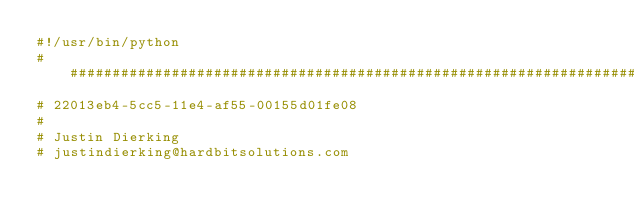Convert code to text. <code><loc_0><loc_0><loc_500><loc_500><_Python_>#!/usr/bin/python
################################################################################
# 22013eb4-5cc5-11e4-af55-00155d01fe08
#
# Justin Dierking
# justindierking@hardbitsolutions.com</code> 